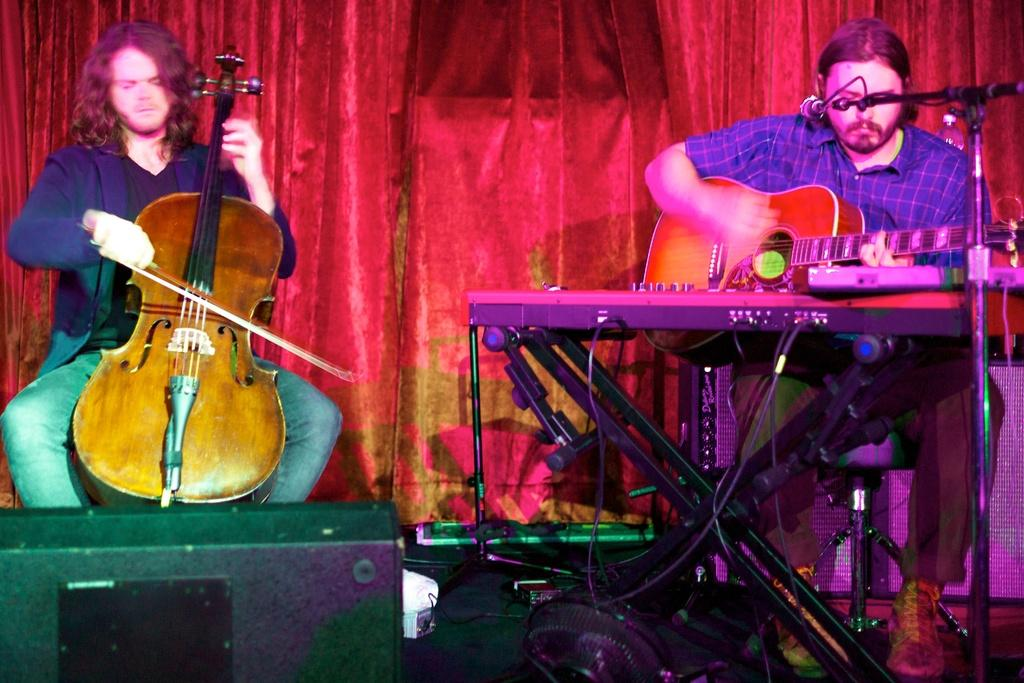How many people are in the image? There are two people in the image. What are the two people doing in the image? The two people are playing musical instruments. What type of flowers can be seen growing around the stone in the image? There is no stone or flowers present in the image; it features two people playing musical instruments. 